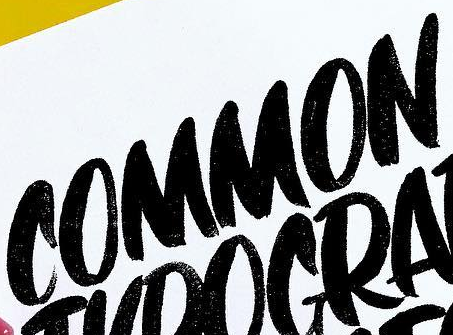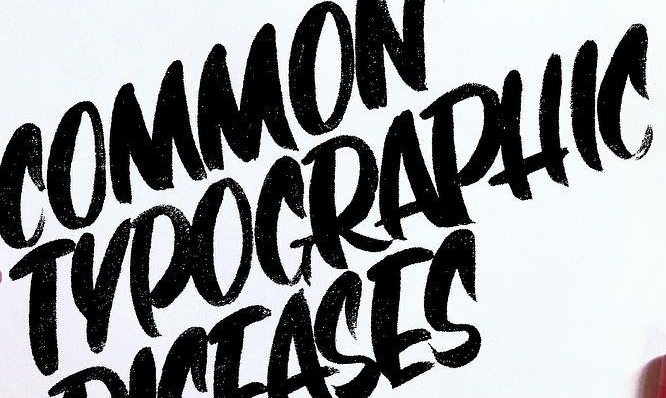What words can you see in these images in sequence, separated by a semicolon? COMMON; TYPOGRAPHIC 